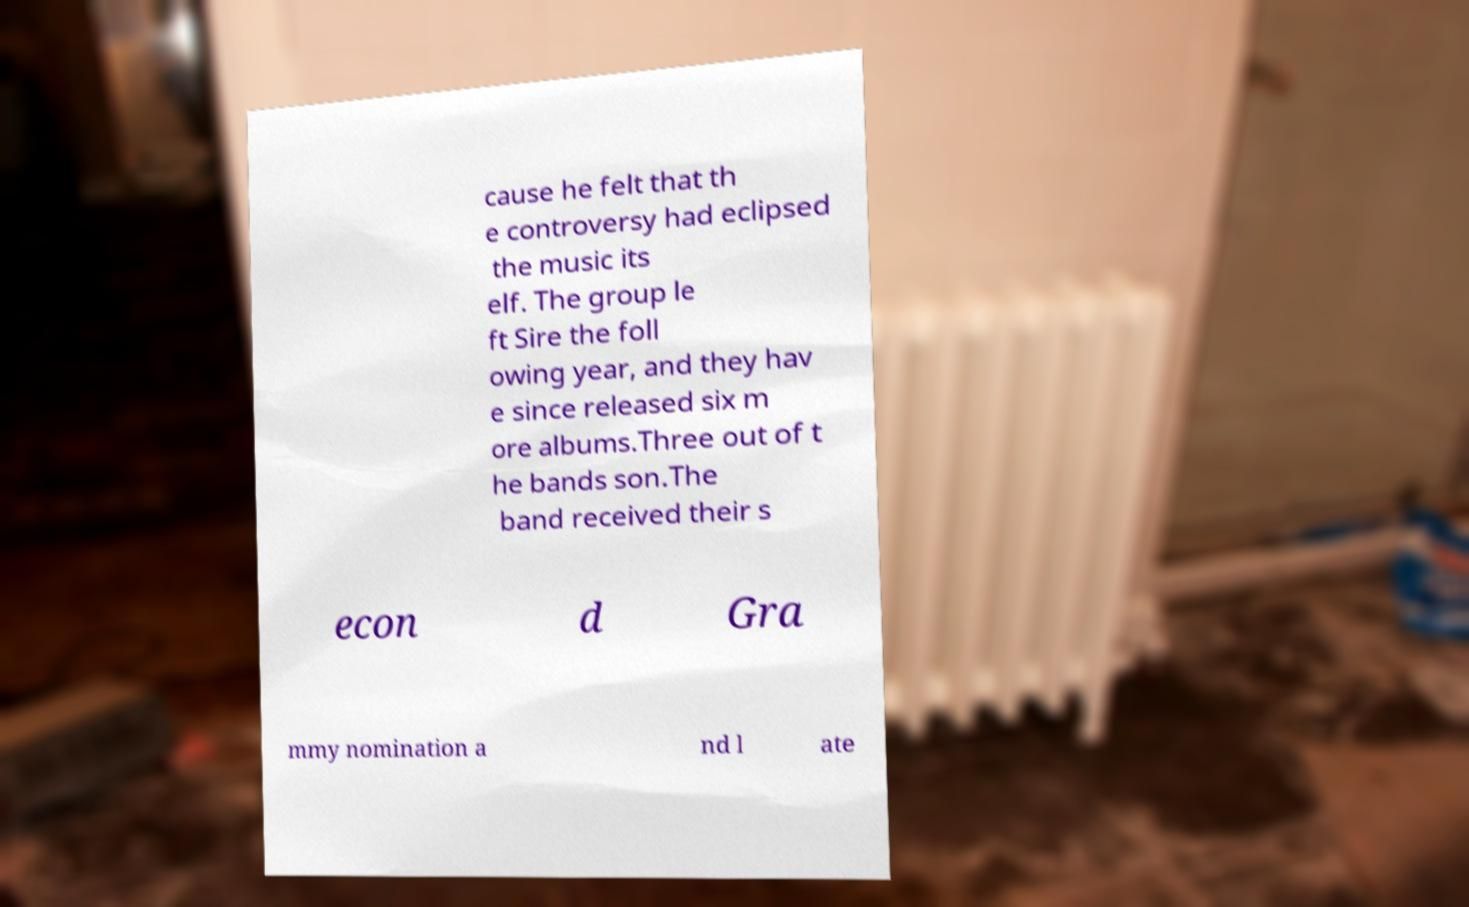For documentation purposes, I need the text within this image transcribed. Could you provide that? cause he felt that th e controversy had eclipsed the music its elf. The group le ft Sire the foll owing year, and they hav e since released six m ore albums.Three out of t he bands son.The band received their s econ d Gra mmy nomination a nd l ate 